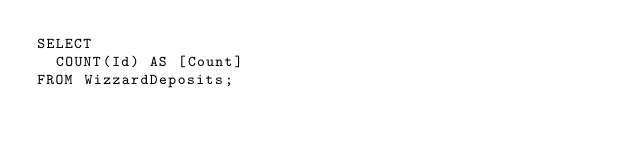<code> <loc_0><loc_0><loc_500><loc_500><_SQL_>SELECT 
	COUNT(Id) AS [Count]
FROM WizzardDeposits;</code> 